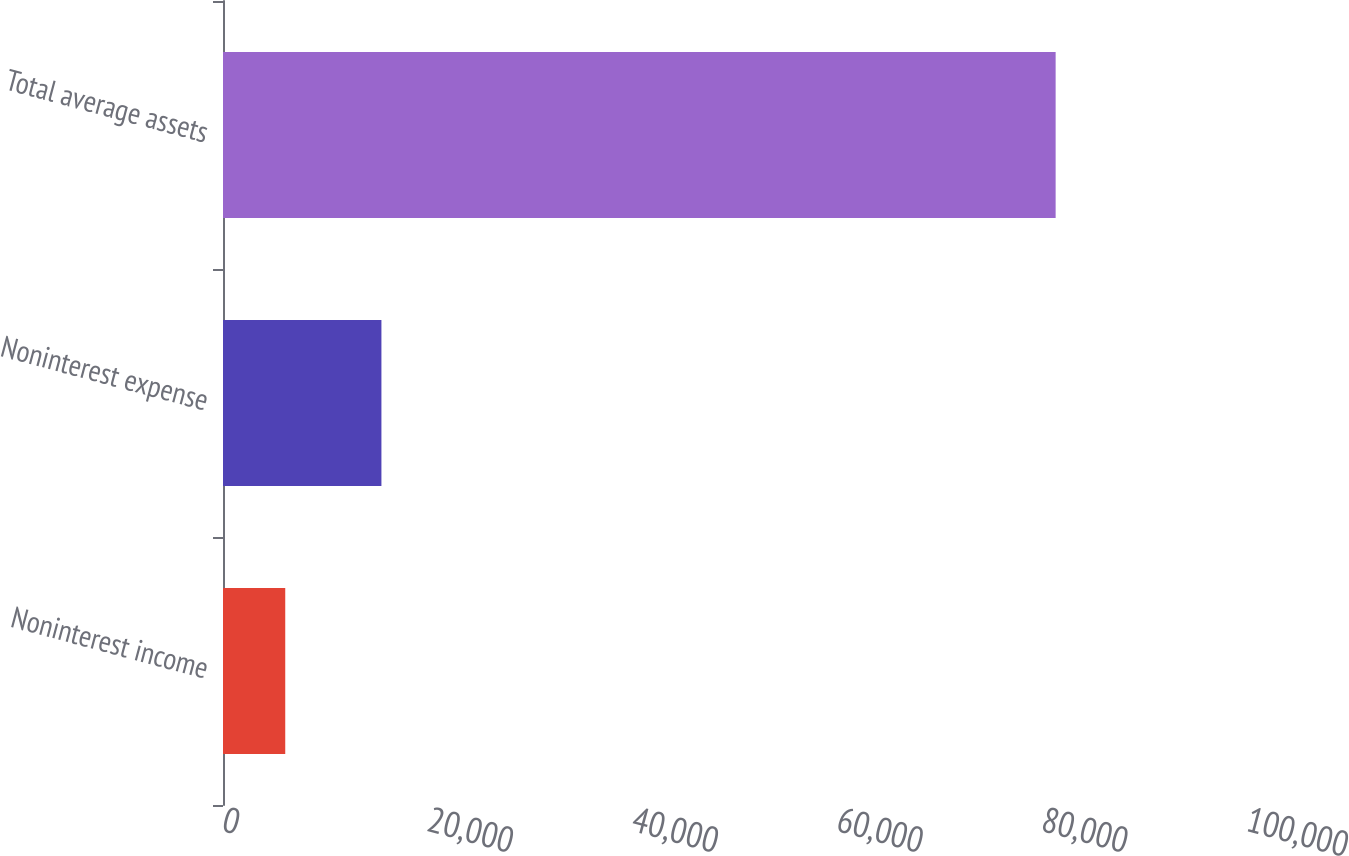Convert chart. <chart><loc_0><loc_0><loc_500><loc_500><bar_chart><fcel>Noninterest income<fcel>Noninterest expense<fcel>Total average assets<nl><fcel>6078<fcel>15471<fcel>81312<nl></chart> 